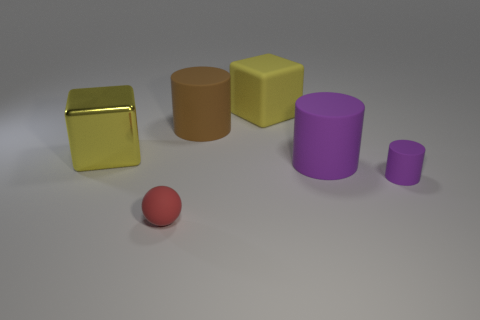Add 1 yellow rubber balls. How many objects exist? 7 Subtract all spheres. How many objects are left? 5 Subtract all small brown shiny blocks. Subtract all big yellow metal objects. How many objects are left? 5 Add 1 big purple objects. How many big purple objects are left? 2 Add 6 small matte objects. How many small matte objects exist? 8 Subtract 0 blue cylinders. How many objects are left? 6 